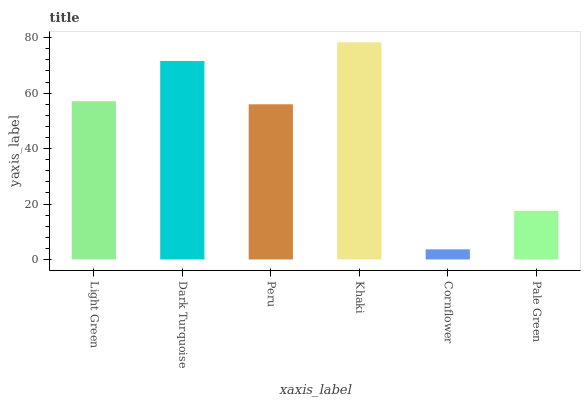Is Cornflower the minimum?
Answer yes or no. Yes. Is Khaki the maximum?
Answer yes or no. Yes. Is Dark Turquoise the minimum?
Answer yes or no. No. Is Dark Turquoise the maximum?
Answer yes or no. No. Is Dark Turquoise greater than Light Green?
Answer yes or no. Yes. Is Light Green less than Dark Turquoise?
Answer yes or no. Yes. Is Light Green greater than Dark Turquoise?
Answer yes or no. No. Is Dark Turquoise less than Light Green?
Answer yes or no. No. Is Light Green the high median?
Answer yes or no. Yes. Is Peru the low median?
Answer yes or no. Yes. Is Dark Turquoise the high median?
Answer yes or no. No. Is Khaki the low median?
Answer yes or no. No. 